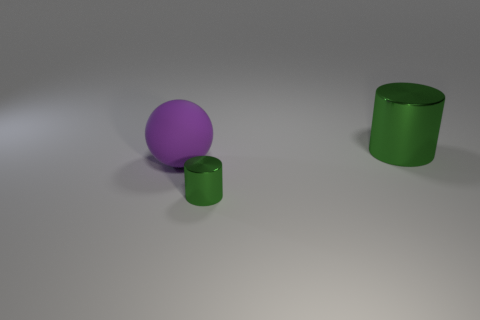What is the size of the other metal thing that is the same shape as the small green metal thing?
Provide a succinct answer. Large. Does the green object that is in front of the big sphere have the same material as the purple thing?
Offer a terse response. No. Is the shape of the purple object the same as the big green thing?
Your answer should be very brief. No. How many things are green metal cylinders on the right side of the tiny metallic cylinder or small metal things?
Your response must be concise. 2. What size is the cylinder that is the same material as the large green object?
Offer a very short reply. Small. How many other things are the same color as the small metal object?
Keep it short and to the point. 1. How many tiny objects are green objects or rubber objects?
Keep it short and to the point. 1. There is another metallic thing that is the same color as the tiny metal thing; what is its size?
Provide a succinct answer. Large. Are there any other large objects that have the same material as the big purple thing?
Offer a terse response. No. There is a big cylinder that is behind the large rubber ball; what material is it?
Make the answer very short. Metal. 